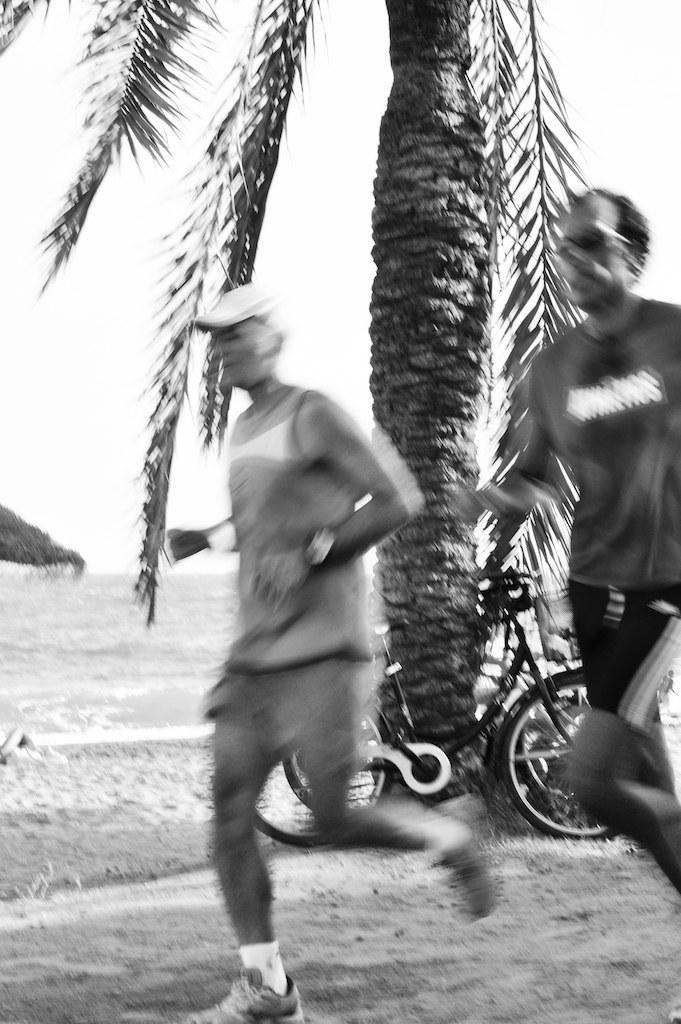How would you summarize this image in a sentence or two? This is a black and white picture. In this picture we can see two people running on the path. There is a bicycle. We can see a tree and a hut in the background. 